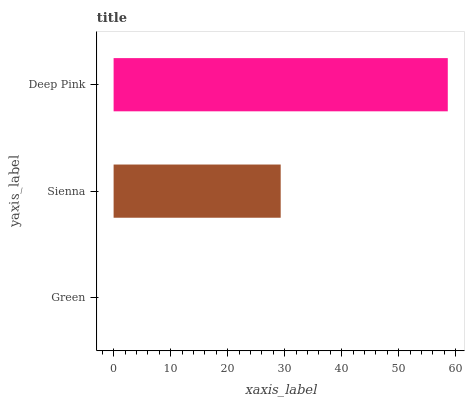Is Green the minimum?
Answer yes or no. Yes. Is Deep Pink the maximum?
Answer yes or no. Yes. Is Sienna the minimum?
Answer yes or no. No. Is Sienna the maximum?
Answer yes or no. No. Is Sienna greater than Green?
Answer yes or no. Yes. Is Green less than Sienna?
Answer yes or no. Yes. Is Green greater than Sienna?
Answer yes or no. No. Is Sienna less than Green?
Answer yes or no. No. Is Sienna the high median?
Answer yes or no. Yes. Is Sienna the low median?
Answer yes or no. Yes. Is Green the high median?
Answer yes or no. No. Is Deep Pink the low median?
Answer yes or no. No. 